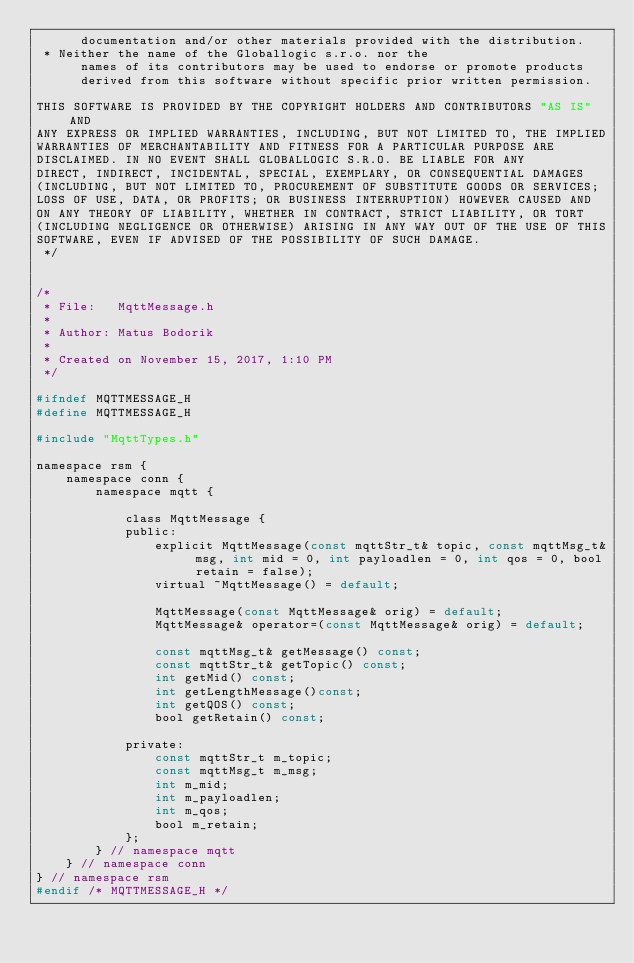<code> <loc_0><loc_0><loc_500><loc_500><_C_>      documentation and/or other materials provided with the distribution.
 * Neither the name of the Globallogic s.r.o. nor the
      names of its contributors may be used to endorse or promote products
      derived from this software without specific prior written permission.

THIS SOFTWARE IS PROVIDED BY THE COPYRIGHT HOLDERS AND CONTRIBUTORS "AS IS" AND
ANY EXPRESS OR IMPLIED WARRANTIES, INCLUDING, BUT NOT LIMITED TO, THE IMPLIED
WARRANTIES OF MERCHANTABILITY AND FITNESS FOR A PARTICULAR PURPOSE ARE
DISCLAIMED. IN NO EVENT SHALL GLOBALLOGIC S.R.O. BE LIABLE FOR ANY
DIRECT, INDIRECT, INCIDENTAL, SPECIAL, EXEMPLARY, OR CONSEQUENTIAL DAMAGES
(INCLUDING, BUT NOT LIMITED TO, PROCUREMENT OF SUBSTITUTE GOODS OR SERVICES;
LOSS OF USE, DATA, OR PROFITS; OR BUSINESS INTERRUPTION) HOWEVER CAUSED AND
ON ANY THEORY OF LIABILITY, WHETHER IN CONTRACT, STRICT LIABILITY, OR TORT
(INCLUDING NEGLIGENCE OR OTHERWISE) ARISING IN ANY WAY OUT OF THE USE OF THIS
SOFTWARE, EVEN IF ADVISED OF THE POSSIBILITY OF SUCH DAMAGE.
 */


/* 
 * File:   MqttMessage.h
 * 
 * Author: Matus Bodorik
 *
 * Created on November 15, 2017, 1:10 PM
 */

#ifndef MQTTMESSAGE_H
#define MQTTMESSAGE_H

#include "MqttTypes.h"

namespace rsm {
    namespace conn {
        namespace mqtt {

            class MqttMessage {
            public:
                explicit MqttMessage(const mqttStr_t& topic, const mqttMsg_t& msg, int mid = 0, int payloadlen = 0, int qos = 0, bool retain = false);
                virtual ~MqttMessage() = default;

                MqttMessage(const MqttMessage& orig) = default;
                MqttMessage& operator=(const MqttMessage& orig) = default;

                const mqttMsg_t& getMessage() const;
                const mqttStr_t& getTopic() const;
                int getMid() const;
                int getLengthMessage()const;
                int getQOS() const;
                bool getRetain() const;

            private:
                const mqttStr_t m_topic;
                const mqttMsg_t m_msg;
                int m_mid;
                int m_payloadlen;
                int m_qos;
                bool m_retain;
            };
        } // namespace mqtt
    } // namespace conn
} // namespace rsm
#endif /* MQTTMESSAGE_H */

</code> 